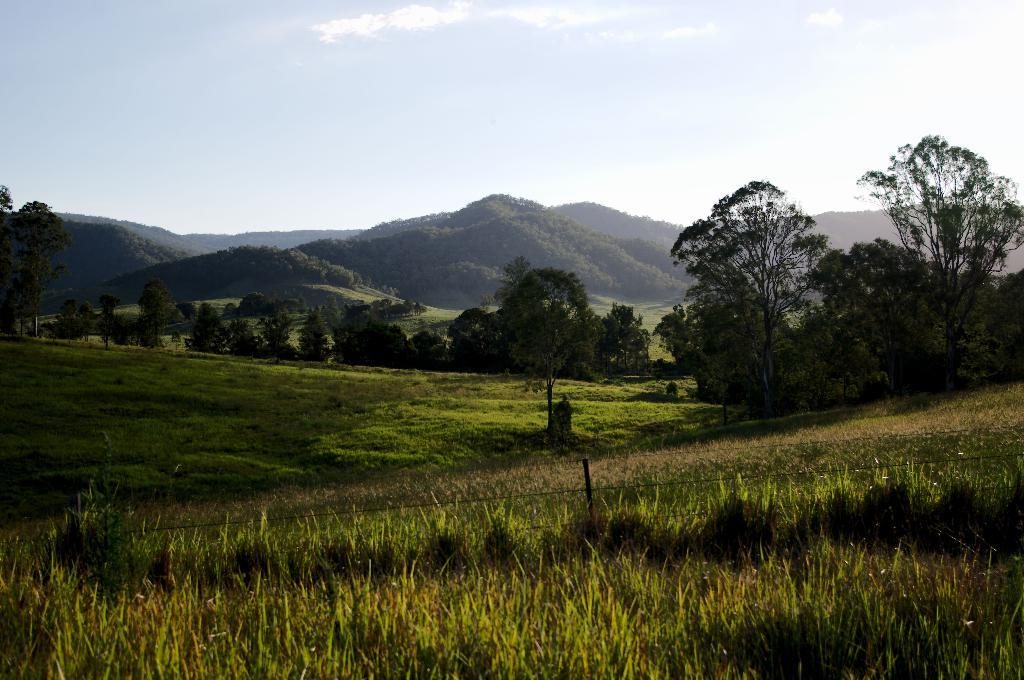What type of vegetation can be seen in the image? There is a group of trees and grass in the image. What structures are present in the image? There is a pole and a fence in the image. What can be seen in the background of the image? Hills and the sky are visible in the background of the image. How would you describe the sky in the image? The sky appears cloudy in the image. What type of plantation is visible in the image? There is no plantation present in the image; it features a group of trees and grass. How is the waste being managed in the image? There is no mention of waste in the image, as it focuses on the natural landscape and structures. 